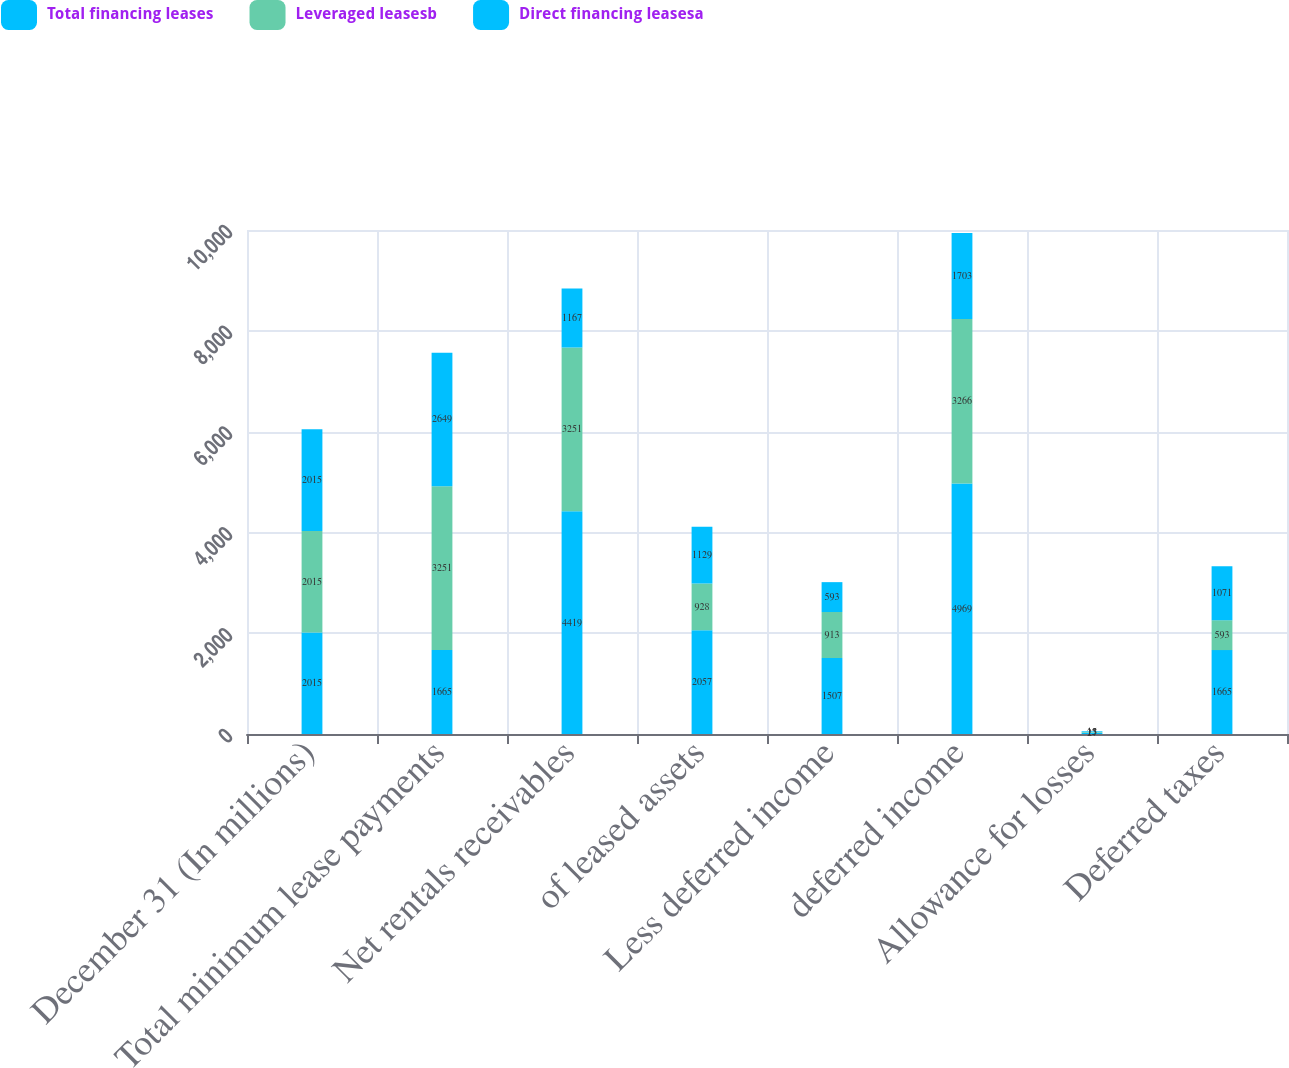<chart> <loc_0><loc_0><loc_500><loc_500><stacked_bar_chart><ecel><fcel>December 31 (In millions)<fcel>Total minimum lease payments<fcel>Net rentals receivables<fcel>of leased assets<fcel>Less deferred income<fcel>deferred income<fcel>Allowance for losses<fcel>Deferred taxes<nl><fcel>Total financing leases<fcel>2015<fcel>1665<fcel>4419<fcel>2057<fcel>1507<fcel>4969<fcel>27<fcel>1665<nl><fcel>Leveraged leasesb<fcel>2015<fcel>3251<fcel>3251<fcel>928<fcel>913<fcel>3266<fcel>15<fcel>593<nl><fcel>Direct financing leasesa<fcel>2015<fcel>2649<fcel>1167<fcel>1129<fcel>593<fcel>1703<fcel>13<fcel>1071<nl></chart> 